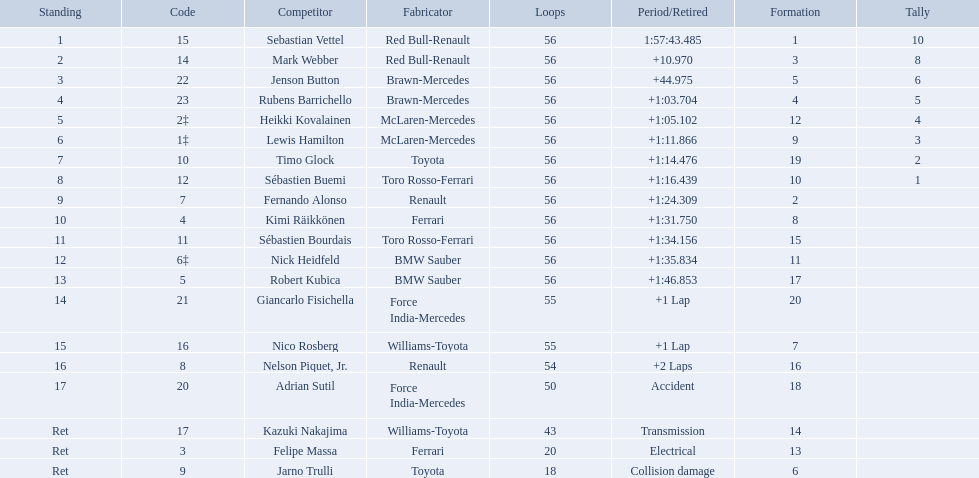Who were all the drivers? Sebastian Vettel, Mark Webber, Jenson Button, Rubens Barrichello, Heikki Kovalainen, Lewis Hamilton, Timo Glock, Sébastien Buemi, Fernando Alonso, Kimi Räikkönen, Sébastien Bourdais, Nick Heidfeld, Robert Kubica, Giancarlo Fisichella, Nico Rosberg, Nelson Piquet, Jr., Adrian Sutil, Kazuki Nakajima, Felipe Massa, Jarno Trulli. Which of these didn't have ferrari as a constructor? Sebastian Vettel, Mark Webber, Jenson Button, Rubens Barrichello, Heikki Kovalainen, Lewis Hamilton, Timo Glock, Sébastien Buemi, Fernando Alonso, Sébastien Bourdais, Nick Heidfeld, Robert Kubica, Giancarlo Fisichella, Nico Rosberg, Nelson Piquet, Jr., Adrian Sutil, Kazuki Nakajima, Jarno Trulli. Which of these was in first place? Sebastian Vettel. Which drivers raced in the 2009 chinese grand prix? Sebastian Vettel, Mark Webber, Jenson Button, Rubens Barrichello, Heikki Kovalainen, Lewis Hamilton, Timo Glock, Sébastien Buemi, Fernando Alonso, Kimi Räikkönen, Sébastien Bourdais, Nick Heidfeld, Robert Kubica, Giancarlo Fisichella, Nico Rosberg, Nelson Piquet, Jr., Adrian Sutil, Kazuki Nakajima, Felipe Massa, Jarno Trulli. Of the drivers in the 2009 chinese grand prix, which finished the race? Sebastian Vettel, Mark Webber, Jenson Button, Rubens Barrichello, Heikki Kovalainen, Lewis Hamilton, Timo Glock, Sébastien Buemi, Fernando Alonso, Kimi Räikkönen, Sébastien Bourdais, Nick Heidfeld, Robert Kubica. Of the drivers who finished the race, who had the slowest time? Robert Kubica. Who are all the drivers? Sebastian Vettel, Mark Webber, Jenson Button, Rubens Barrichello, Heikki Kovalainen, Lewis Hamilton, Timo Glock, Sébastien Buemi, Fernando Alonso, Kimi Räikkönen, Sébastien Bourdais, Nick Heidfeld, Robert Kubica, Giancarlo Fisichella, Nico Rosberg, Nelson Piquet, Jr., Adrian Sutil, Kazuki Nakajima, Felipe Massa, Jarno Trulli. What were their finishing times? 1:57:43.485, +10.970, +44.975, +1:03.704, +1:05.102, +1:11.866, +1:14.476, +1:16.439, +1:24.309, +1:31.750, +1:34.156, +1:35.834, +1:46.853, +1 Lap, +1 Lap, +2 Laps, Accident, Transmission, Electrical, Collision damage. Who finished last? Robert Kubica. Would you be able to parse every entry in this table? {'header': ['Standing', 'Code', 'Competitor', 'Fabricator', 'Loops', 'Period/Retired', 'Formation', 'Tally'], 'rows': [['1', '15', 'Sebastian Vettel', 'Red Bull-Renault', '56', '1:57:43.485', '1', '10'], ['2', '14', 'Mark Webber', 'Red Bull-Renault', '56', '+10.970', '3', '8'], ['3', '22', 'Jenson Button', 'Brawn-Mercedes', '56', '+44.975', '5', '6'], ['4', '23', 'Rubens Barrichello', 'Brawn-Mercedes', '56', '+1:03.704', '4', '5'], ['5', '2‡', 'Heikki Kovalainen', 'McLaren-Mercedes', '56', '+1:05.102', '12', '4'], ['6', '1‡', 'Lewis Hamilton', 'McLaren-Mercedes', '56', '+1:11.866', '9', '3'], ['7', '10', 'Timo Glock', 'Toyota', '56', '+1:14.476', '19', '2'], ['8', '12', 'Sébastien Buemi', 'Toro Rosso-Ferrari', '56', '+1:16.439', '10', '1'], ['9', '7', 'Fernando Alonso', 'Renault', '56', '+1:24.309', '2', ''], ['10', '4', 'Kimi Räikkönen', 'Ferrari', '56', '+1:31.750', '8', ''], ['11', '11', 'Sébastien Bourdais', 'Toro Rosso-Ferrari', '56', '+1:34.156', '15', ''], ['12', '6‡', 'Nick Heidfeld', 'BMW Sauber', '56', '+1:35.834', '11', ''], ['13', '5', 'Robert Kubica', 'BMW Sauber', '56', '+1:46.853', '17', ''], ['14', '21', 'Giancarlo Fisichella', 'Force India-Mercedes', '55', '+1 Lap', '20', ''], ['15', '16', 'Nico Rosberg', 'Williams-Toyota', '55', '+1 Lap', '7', ''], ['16', '8', 'Nelson Piquet, Jr.', 'Renault', '54', '+2 Laps', '16', ''], ['17', '20', 'Adrian Sutil', 'Force India-Mercedes', '50', 'Accident', '18', ''], ['Ret', '17', 'Kazuki Nakajima', 'Williams-Toyota', '43', 'Transmission', '14', ''], ['Ret', '3', 'Felipe Massa', 'Ferrari', '20', 'Electrical', '13', ''], ['Ret', '9', 'Jarno Trulli', 'Toyota', '18', 'Collision damage', '6', '']]} Who were the drivers at the 2009 chinese grand prix? Sebastian Vettel, Mark Webber, Jenson Button, Rubens Barrichello, Heikki Kovalainen, Lewis Hamilton, Timo Glock, Sébastien Buemi, Fernando Alonso, Kimi Räikkönen, Sébastien Bourdais, Nick Heidfeld, Robert Kubica, Giancarlo Fisichella, Nico Rosberg, Nelson Piquet, Jr., Adrian Sutil, Kazuki Nakajima, Felipe Massa, Jarno Trulli. Who had the slowest time? Robert Kubica. Why did the  toyota retire Collision damage. What was the drivers name? Jarno Trulli. 